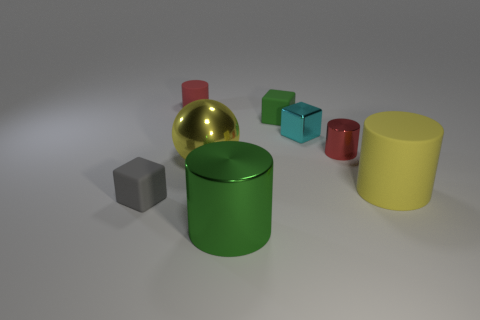Are there more tiny cubes in front of the yellow cylinder than large red matte blocks?
Provide a short and direct response. Yes. What is the cylinder that is on the left side of the tiny red metallic thing and behind the yellow rubber object made of?
Your answer should be compact. Rubber. Is there anything else that has the same shape as the large yellow metal thing?
Keep it short and to the point. No. What number of tiny cubes are both in front of the large matte cylinder and behind the yellow rubber cylinder?
Give a very brief answer. 0. What material is the cyan cube?
Offer a terse response. Metal. Are there an equal number of gray rubber cubes right of the big green metallic object and small yellow metallic cubes?
Make the answer very short. Yes. What number of other tiny metallic things have the same shape as the gray thing?
Give a very brief answer. 1. Do the red matte thing and the gray matte thing have the same shape?
Your response must be concise. No. How many objects are either tiny cyan metal cubes right of the tiny green thing or big yellow metal things?
Your answer should be very brief. 2. There is a yellow thing that is right of the tiny red object that is right of the metallic object that is in front of the big yellow metallic sphere; what is its shape?
Provide a short and direct response. Cylinder. 